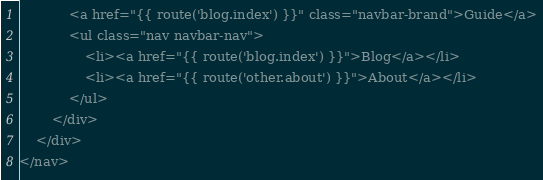Convert code to text. <code><loc_0><loc_0><loc_500><loc_500><_PHP_>            <a href="{{ route('blog.index') }}" class="navbar-brand">Guide</a>
            <ul class="nav navbar-nav">
                <li><a href="{{ route('blog.index') }}">Blog</a></li>
                <li><a href="{{ route('other.about') }}">About</a></li>
            </ul>
        </div>
    </div>
</nav></code> 